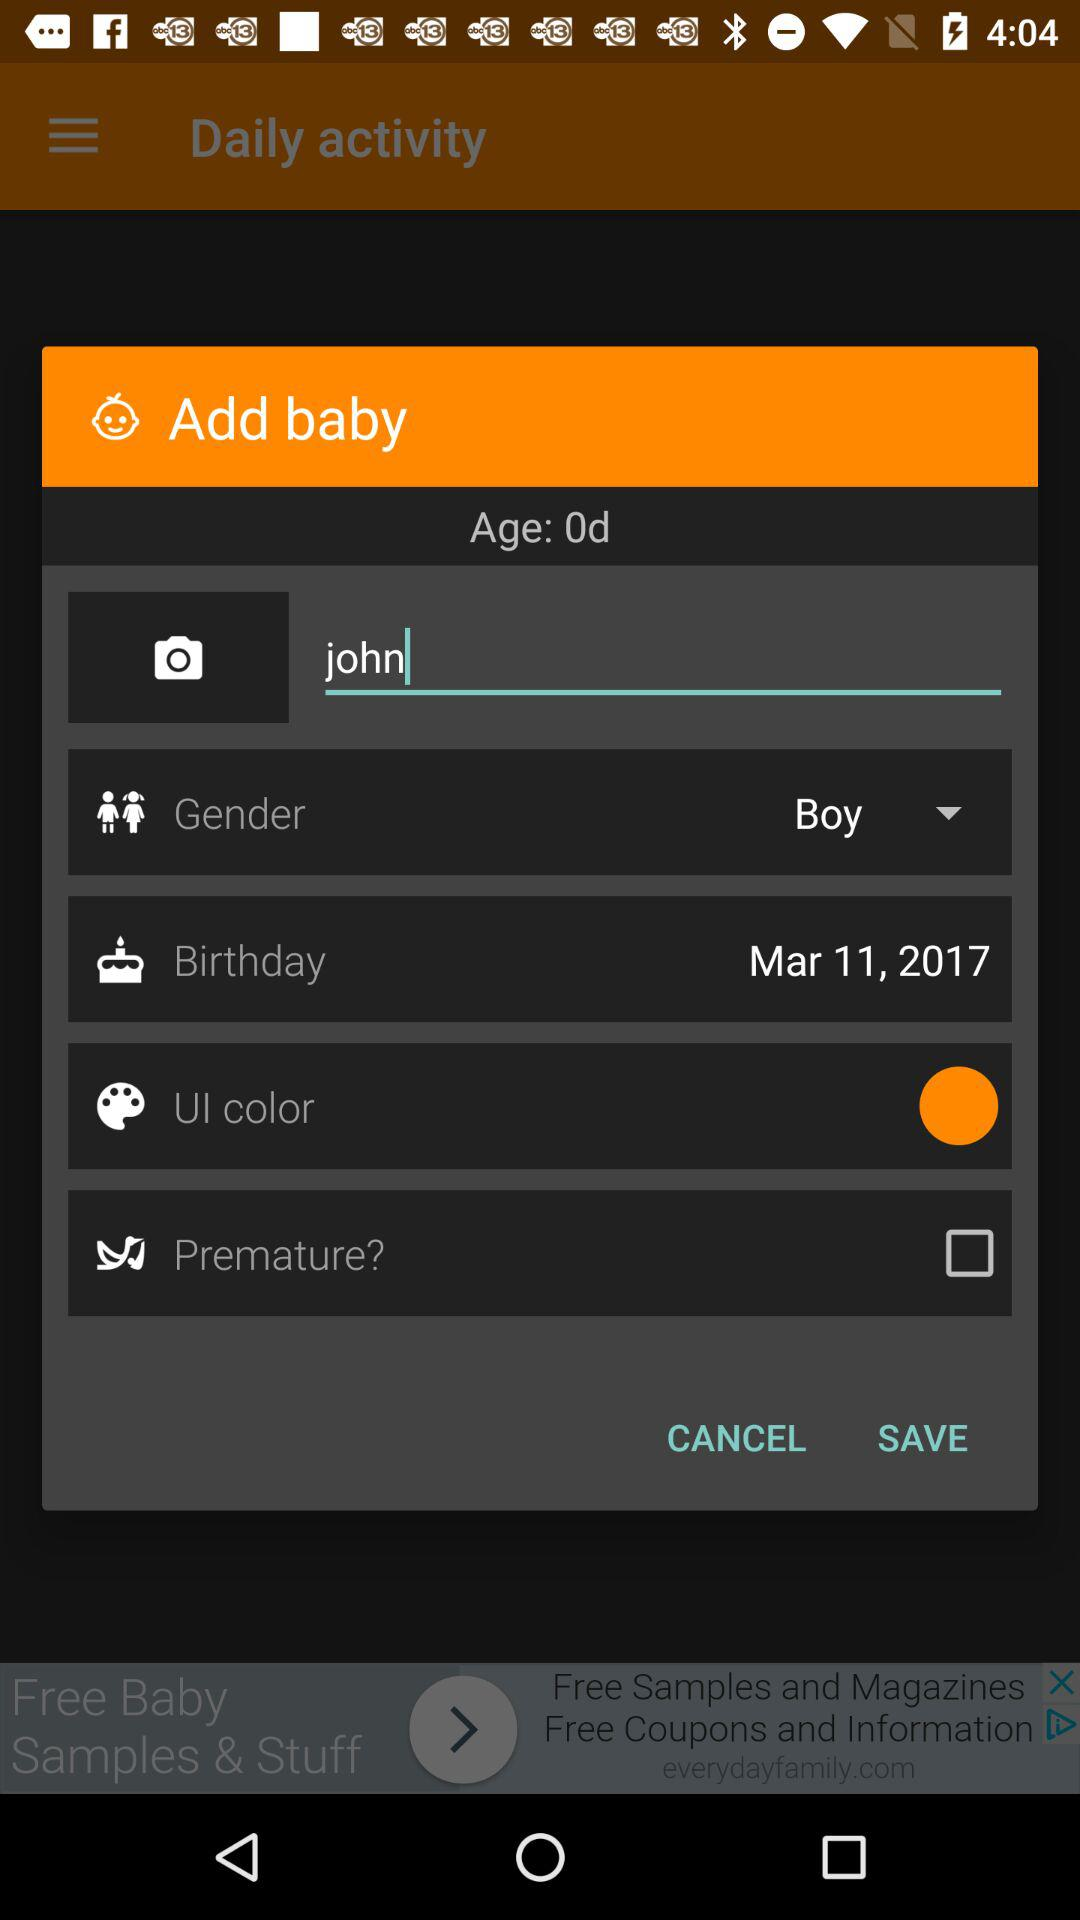What is the gender of the baby? The gender of the baby is a boy. 